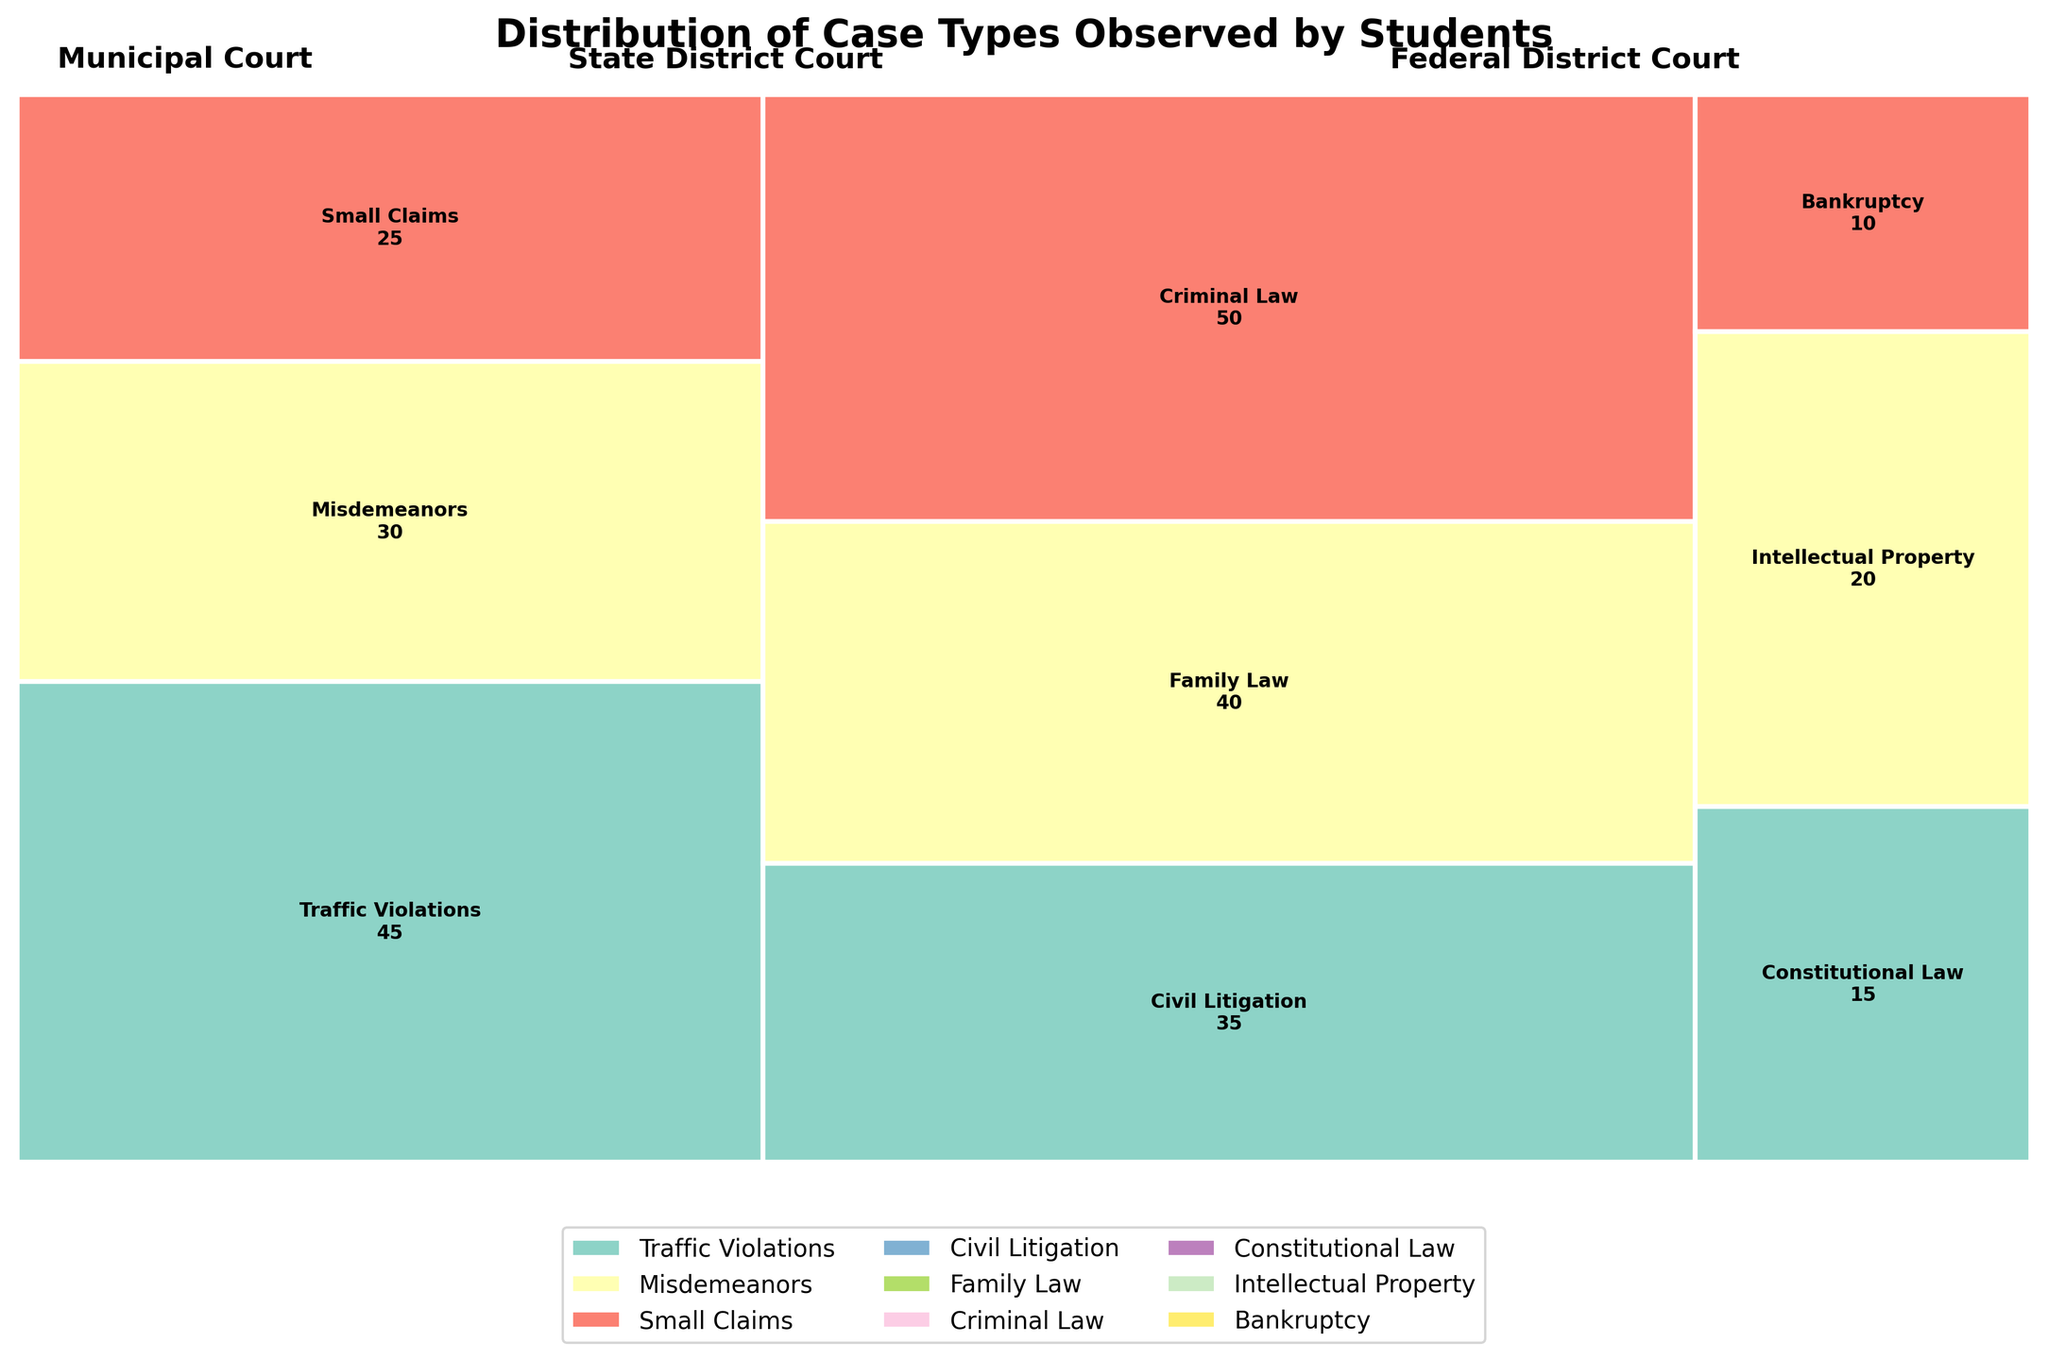What's the title of the mosaic plot? The title is usually placed at the top of the figure, prominently displayed in bold text. In this case, the title is "Distribution of Case Types Observed by Students," as indicated in the provided code.
Answer: Distribution of Case Types Observed by Students What court level has the largest overall number of cases? Looking at the width of the rectangle segments, the widest section represents the court level with the most cases. The Municipal Court, which has the widest section, indicating it has the largest overall number of cases.
Answer: Municipal Court Which legal domain has the smallest number of cases observed in the Federal District Court? In the Federal District Court section, the smallest segment corresponds to the Bankruptcy legal domain with the fewest cases.
Answer: Bankruptcy How many cases of Traffic Violations were observed by students in the Municipal Court? The number of cases is provided inside each rectangle. For Traffic Violations in the Municipal Court, the number 45 is annotated within its segment.
Answer: 45 Compare the number of Family Law cases in the State District Court to the number of Intellectual Property cases in the Federal District Court. Which one is more? By checking the annotations, there are 40 Family Law cases in the State District Court and 20 Intellectual Property cases in the Federal District Court. Hence, Family Law cases are more.
Answer: Family Law Which legal domain in the State District Court has the highest number of cases? Observe the height of different segments within the State District Court. The Criminal Law segment is the tallest, indicating it has the highest number of cases (50).
Answer: Criminal Law What is the total number of cases observed by students in Federal District Court? Sum the number of cases in all legal domains in the Federal District Court: Constitutional Law (15), Intellectual Property (20), and Bankruptcy (10). The total is 15 + 20 + 10 = 45.
Answer: 45 What proportion of the total number of cases in Municipal Court does Small Claims represent? To find the proportion, divide the number of Small Claims cases (25) by the total number of cases in Municipal Court (45 + 30 + 25 = 100). The proportion is 25 / 100 = 0.25 (25%).
Answer: 25% How does the width of the State District Court segment compare to the width of the Federal District Court segment? By observing the relative widths of the segments, the State District Court segment is wider compared to the Federal District Court segment, indicating it has more cases overall.
Answer: State is wider Which court level includes Traffic Violations cases? Traffic Violations cases can be seen in the segment labeled Municipal Court.
Answer: Municipal Court 